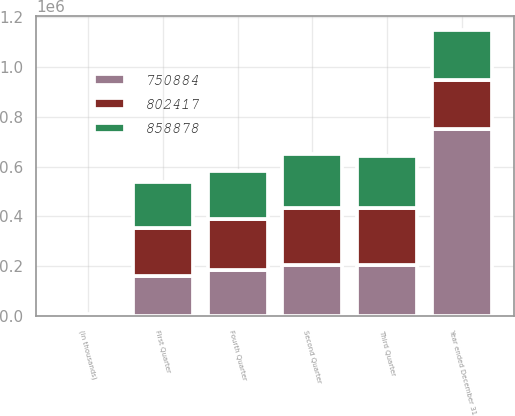<chart> <loc_0><loc_0><loc_500><loc_500><stacked_bar_chart><ecel><fcel>(in thousands)<fcel>First Quarter<fcel>Second Quarter<fcel>Third Quarter<fcel>Fourth Quarter<fcel>Year ended December 31<nl><fcel>802417<fcel>2006<fcel>194187<fcel>232222<fcel>227816<fcel>204653<fcel>198778<nl><fcel>858878<fcel>2005<fcel>183915<fcel>214326<fcel>209346<fcel>194830<fcel>198778<nl><fcel>750884<fcel>2004<fcel>160416<fcel>202725<fcel>203925<fcel>183818<fcel>750884<nl></chart> 